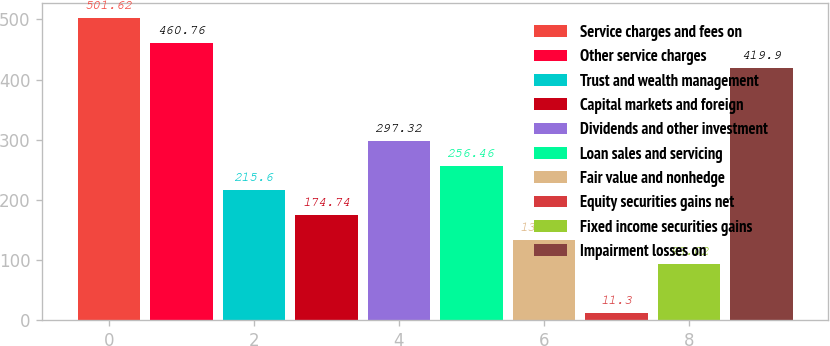Convert chart to OTSL. <chart><loc_0><loc_0><loc_500><loc_500><bar_chart><fcel>Service charges and fees on<fcel>Other service charges<fcel>Trust and wealth management<fcel>Capital markets and foreign<fcel>Dividends and other investment<fcel>Loan sales and servicing<fcel>Fair value and nonhedge<fcel>Equity securities gains net<fcel>Fixed income securities gains<fcel>Impairment losses on<nl><fcel>501.62<fcel>460.76<fcel>215.6<fcel>174.74<fcel>297.32<fcel>256.46<fcel>133.88<fcel>11.3<fcel>93.02<fcel>419.9<nl></chart> 